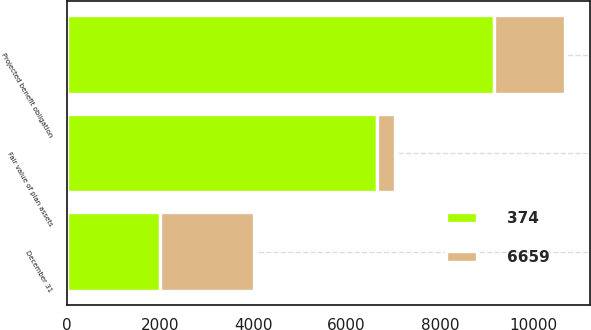Convert chart to OTSL. <chart><loc_0><loc_0><loc_500><loc_500><stacked_bar_chart><ecel><fcel>December 31<fcel>Projected benefit obligation<fcel>Fair value of plan assets<nl><fcel>6659<fcel>2013<fcel>1521<fcel>374<nl><fcel>374<fcel>2012<fcel>9161<fcel>6659<nl></chart> 